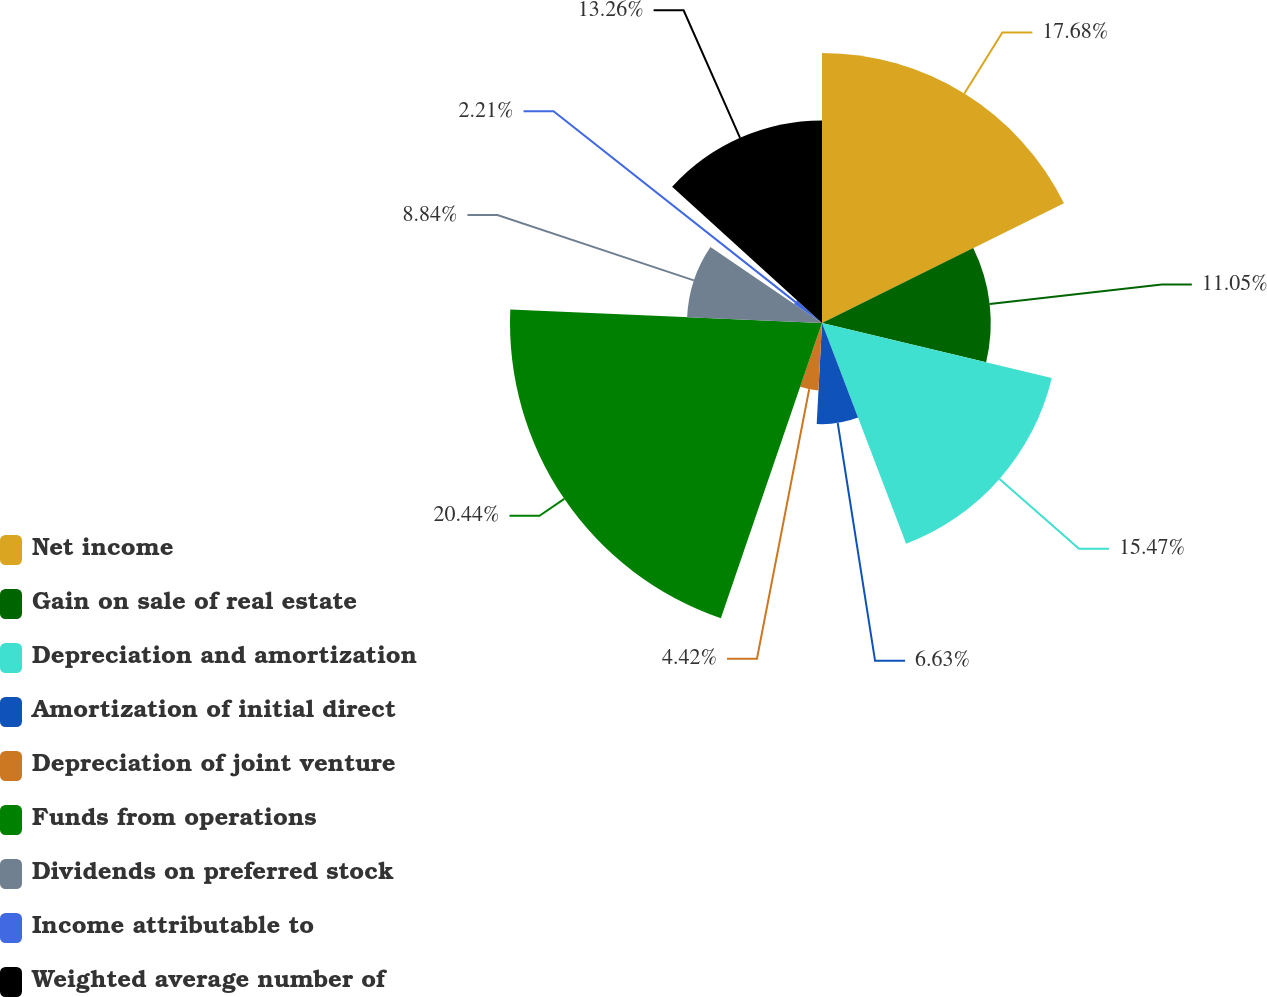Convert chart. <chart><loc_0><loc_0><loc_500><loc_500><pie_chart><fcel>Net income<fcel>Gain on sale of real estate<fcel>Depreciation and amortization<fcel>Amortization of initial direct<fcel>Depreciation of joint venture<fcel>Funds from operations<fcel>Dividends on preferred stock<fcel>Income attributable to<fcel>Weighted average number of<nl><fcel>17.68%<fcel>11.05%<fcel>15.47%<fcel>6.63%<fcel>4.42%<fcel>20.43%<fcel>8.84%<fcel>2.21%<fcel>13.26%<nl></chart> 